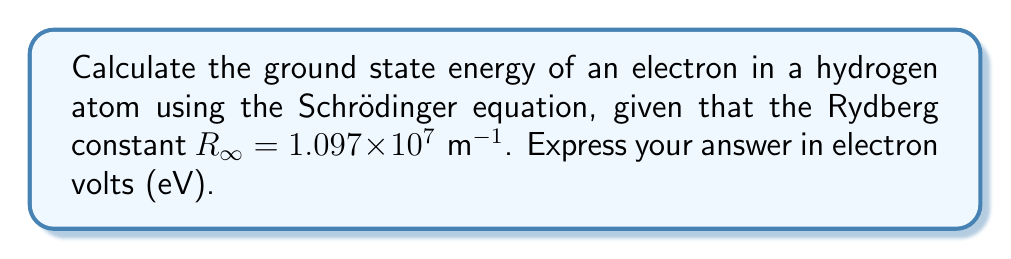What is the answer to this math problem? To solve this problem, we'll follow these steps:

1) The energy levels of a hydrogen atom are given by the equation:

   $$E_n = -\frac{R_\infty hc}{n^2}$$

   where $E_n$ is the energy of the nth level, $h$ is Planck's constant, $c$ is the speed of light, and $n$ is the principal quantum number.

2) For the ground state, $n = 1$. So we're looking for $E_1$.

3) Let's substitute the known values:
   $R_\infty = 1.097 \times 10^7 \text{ m}^{-1}$
   $h = 6.626 \times 10^{-34} \text{ J⋅s}$
   $c = 2.998 \times 10^8 \text{ m/s}$

4) Calculating:

   $$E_1 = -\frac{(1.097 \times 10^7)(6.626 \times 10^{-34})(2.998 \times 10^8)}{1^2}$$

5) This gives us:
   
   $$E_1 = -2.18 \times 10^{-18} \text{ J}$$

6) To convert from Joules to electron volts, we divide by the charge of an electron:
   $1 \text{ eV} = 1.602 \times 10^{-19} \text{ J}$

   $$E_1 \text{ (in eV)} = \frac{-2.18 \times 10^{-18}}{1.602 \times 10^{-19}} = -13.6 \text{ eV}$$
Answer: $-13.6 \text{ eV}$ 